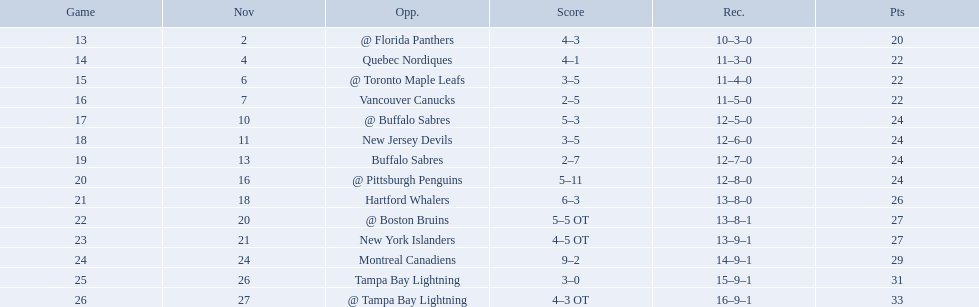Who did the philadelphia flyers play in game 17? @ Buffalo Sabres. What was the score of the november 10th game against the buffalo sabres? 5–3. Which team in the atlantic division had less points than the philadelphia flyers? Tampa Bay Lightning. Which teams scored 35 points or more in total? Hartford Whalers, @ Boston Bruins, New York Islanders, Montreal Canadiens, Tampa Bay Lightning, @ Tampa Bay Lightning. Would you be able to parse every entry in this table? {'header': ['Game', 'Nov', 'Opp.', 'Score', 'Rec.', 'Pts'], 'rows': [['13', '2', '@ Florida Panthers', '4–3', '10–3–0', '20'], ['14', '4', 'Quebec Nordiques', '4–1', '11–3–0', '22'], ['15', '6', '@ Toronto Maple Leafs', '3–5', '11–4–0', '22'], ['16', '7', 'Vancouver Canucks', '2–5', '11–5–0', '22'], ['17', '10', '@ Buffalo Sabres', '5–3', '12–5–0', '24'], ['18', '11', 'New Jersey Devils', '3–5', '12–6–0', '24'], ['19', '13', 'Buffalo Sabres', '2–7', '12–7–0', '24'], ['20', '16', '@ Pittsburgh Penguins', '5–11', '12–8–0', '24'], ['21', '18', 'Hartford Whalers', '6–3', '13–8–0', '26'], ['22', '20', '@ Boston Bruins', '5–5 OT', '13–8–1', '27'], ['23', '21', 'New York Islanders', '4–5 OT', '13–9–1', '27'], ['24', '24', 'Montreal Canadiens', '9–2', '14–9–1', '29'], ['25', '26', 'Tampa Bay Lightning', '3–0', '15–9–1', '31'], ['26', '27', '@ Tampa Bay Lightning', '4–3 OT', '16–9–1', '33']]} Of those teams, which team was the only one to score 3-0? Tampa Bay Lightning. What are the teams in the atlantic division? Quebec Nordiques, Vancouver Canucks, New Jersey Devils, Buffalo Sabres, Hartford Whalers, New York Islanders, Montreal Canadiens, Tampa Bay Lightning. Which of those scored fewer points than the philadelphia flyers? Tampa Bay Lightning. What were the scores? @ Florida Panthers, 4–3, Quebec Nordiques, 4–1, @ Toronto Maple Leafs, 3–5, Vancouver Canucks, 2–5, @ Buffalo Sabres, 5–3, New Jersey Devils, 3–5, Buffalo Sabres, 2–7, @ Pittsburgh Penguins, 5–11, Hartford Whalers, 6–3, @ Boston Bruins, 5–5 OT, New York Islanders, 4–5 OT, Montreal Canadiens, 9–2, Tampa Bay Lightning, 3–0, @ Tampa Bay Lightning, 4–3 OT. What score was the closest? New York Islanders, 4–5 OT. What team had that score? New York Islanders. 